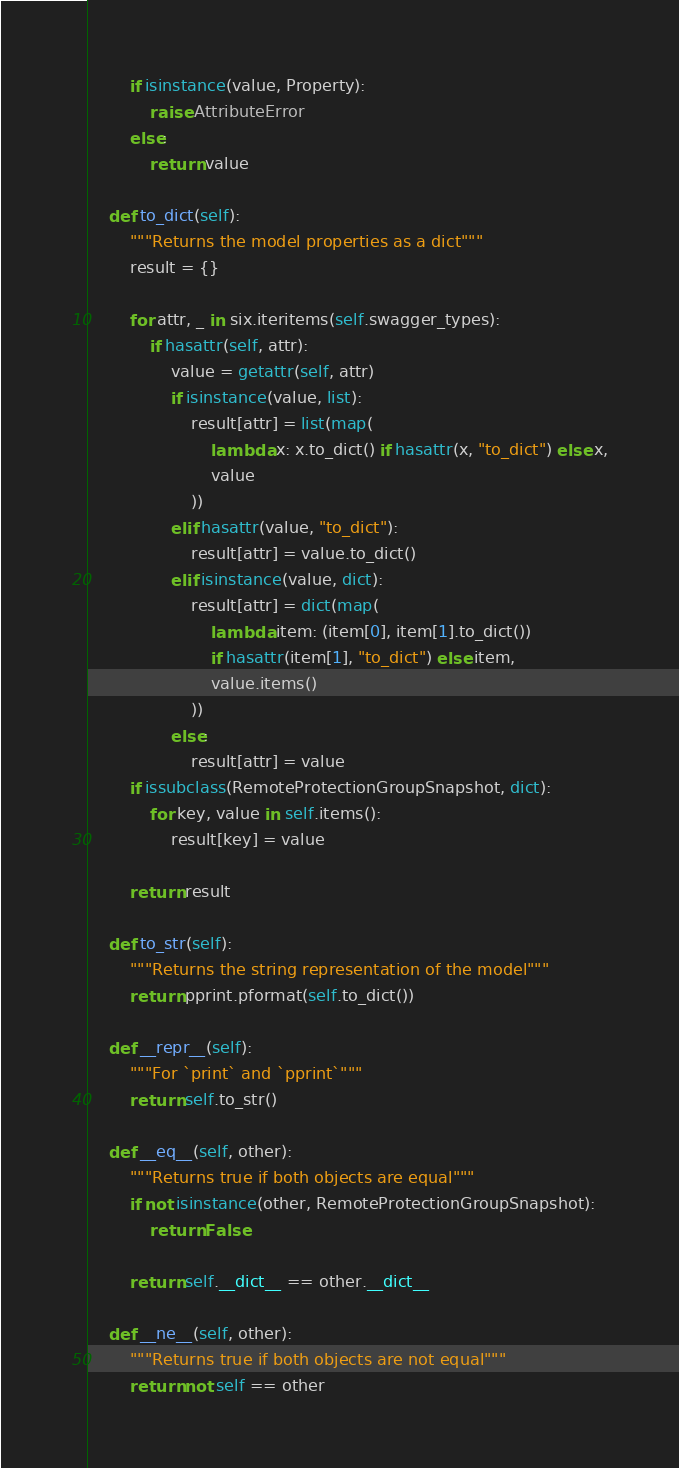Convert code to text. <code><loc_0><loc_0><loc_500><loc_500><_Python_>        if isinstance(value, Property):
            raise AttributeError
        else:
            return value

    def to_dict(self):
        """Returns the model properties as a dict"""
        result = {}

        for attr, _ in six.iteritems(self.swagger_types):
            if hasattr(self, attr):
                value = getattr(self, attr)
                if isinstance(value, list):
                    result[attr] = list(map(
                        lambda x: x.to_dict() if hasattr(x, "to_dict") else x,
                        value
                    ))
                elif hasattr(value, "to_dict"):
                    result[attr] = value.to_dict()
                elif isinstance(value, dict):
                    result[attr] = dict(map(
                        lambda item: (item[0], item[1].to_dict())
                        if hasattr(item[1], "to_dict") else item,
                        value.items()
                    ))
                else:
                    result[attr] = value
        if issubclass(RemoteProtectionGroupSnapshot, dict):
            for key, value in self.items():
                result[key] = value

        return result

    def to_str(self):
        """Returns the string representation of the model"""
        return pprint.pformat(self.to_dict())

    def __repr__(self):
        """For `print` and `pprint`"""
        return self.to_str()

    def __eq__(self, other):
        """Returns true if both objects are equal"""
        if not isinstance(other, RemoteProtectionGroupSnapshot):
            return False

        return self.__dict__ == other.__dict__

    def __ne__(self, other):
        """Returns true if both objects are not equal"""
        return not self == other
</code> 